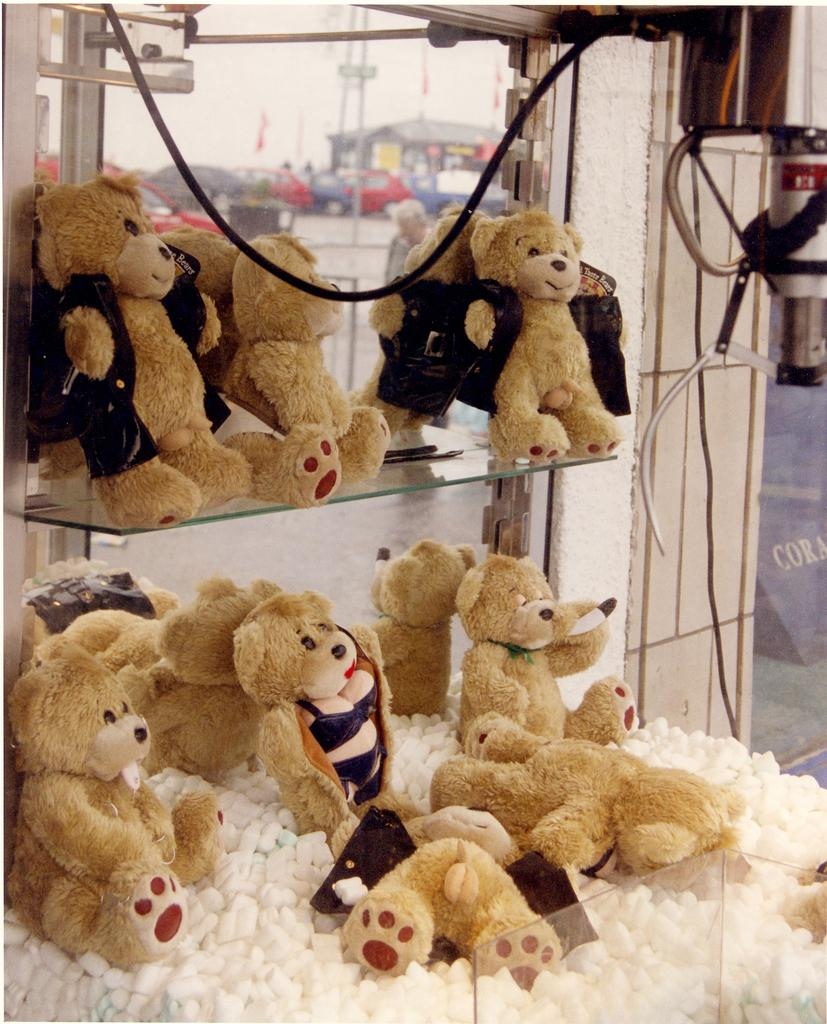What objects can be seen on the left side of the image? There are toys on the left side of the image. What structure is located on the right side of the image? There is a pillar on the right side of the image. What else can be seen on the right side of the image? There are wires on the right side of the image. What can be seen in the background of the image? There are cars and a house in the background of the image. How does the rod affect the hate in the image? There is no rod or hate present in the image. What type of adjustment is needed for the house in the image? There is no adjustment needed for the house in the image, as it is a static background element. 